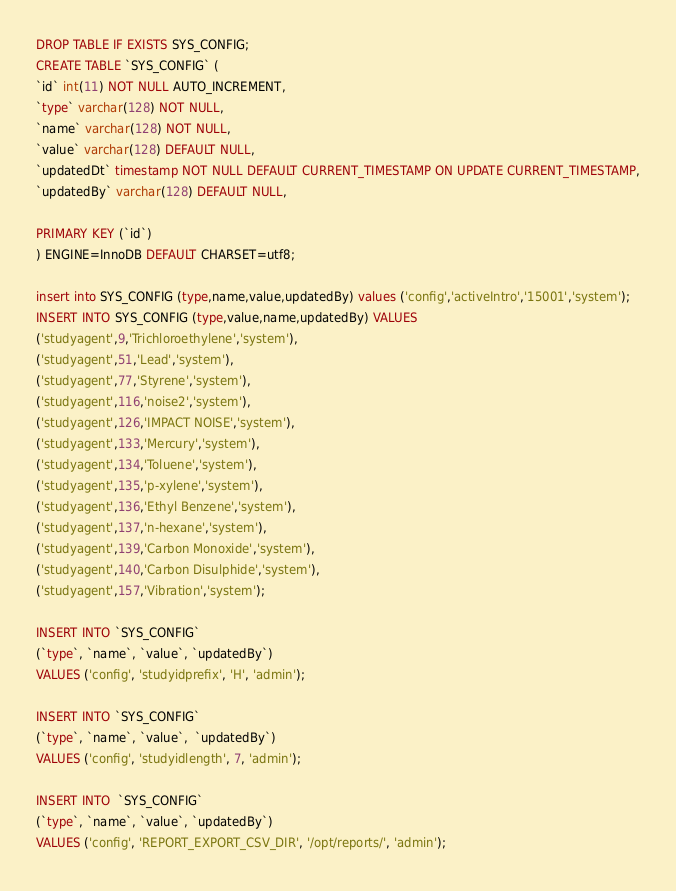<code> <loc_0><loc_0><loc_500><loc_500><_SQL_>DROP TABLE IF EXISTS SYS_CONFIG;
CREATE TABLE `SYS_CONFIG` (
`id` int(11) NOT NULL AUTO_INCREMENT,
`type` varchar(128) NOT NULL,
`name` varchar(128) NOT NULL,
`value` varchar(128) DEFAULT NULL,
`updatedDt` timestamp NOT NULL DEFAULT CURRENT_TIMESTAMP ON UPDATE CURRENT_TIMESTAMP,
`updatedBy` varchar(128) DEFAULT NULL,

PRIMARY KEY (`id`)
) ENGINE=InnoDB DEFAULT CHARSET=utf8;

insert into SYS_CONFIG (type,name,value,updatedBy) values ('config','activeIntro','15001','system');
INSERT INTO SYS_CONFIG (type,value,name,updatedBy) VALUES 
('studyagent',9,'Trichloroethylene','system'),
('studyagent',51,'Lead','system'),
('studyagent',77,'Styrene','system'),
('studyagent',116,'noise2','system'),
('studyagent',126,'IMPACT NOISE','system'),
('studyagent',133,'Mercury','system'),
('studyagent',134,'Toluene','system'),
('studyagent',135,'p-xylene','system'),
('studyagent',136,'Ethyl Benzene','system'),
('studyagent',137,'n-hexane','system'),
('studyagent',139,'Carbon Monoxide','system'),
('studyagent',140,'Carbon Disulphide','system'),
('studyagent',157,'Vibration','system');

INSERT INTO `SYS_CONFIG` 
(`type`, `name`, `value`, `updatedBy`) 
VALUES ('config', 'studyidprefix', 'H', 'admin');

INSERT INTO `SYS_CONFIG` 
(`type`, `name`, `value`,  `updatedBy`) 
VALUES ('config', 'studyidlength', 7, 'admin');

INSERT INTO  `SYS_CONFIG` 
(`type`, `name`, `value`, `updatedBy`) 
VALUES ('config', 'REPORT_EXPORT_CSV_DIR', '/opt/reports/', 'admin');

</code> 